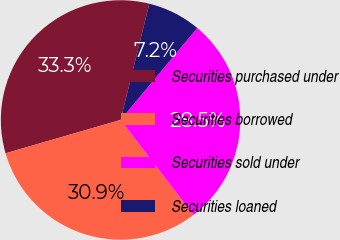<chart> <loc_0><loc_0><loc_500><loc_500><pie_chart><fcel>Securities purchased under<fcel>Securities borrowed<fcel>Securities sold under<fcel>Securities loaned<nl><fcel>33.35%<fcel>30.93%<fcel>28.52%<fcel>7.2%<nl></chart> 